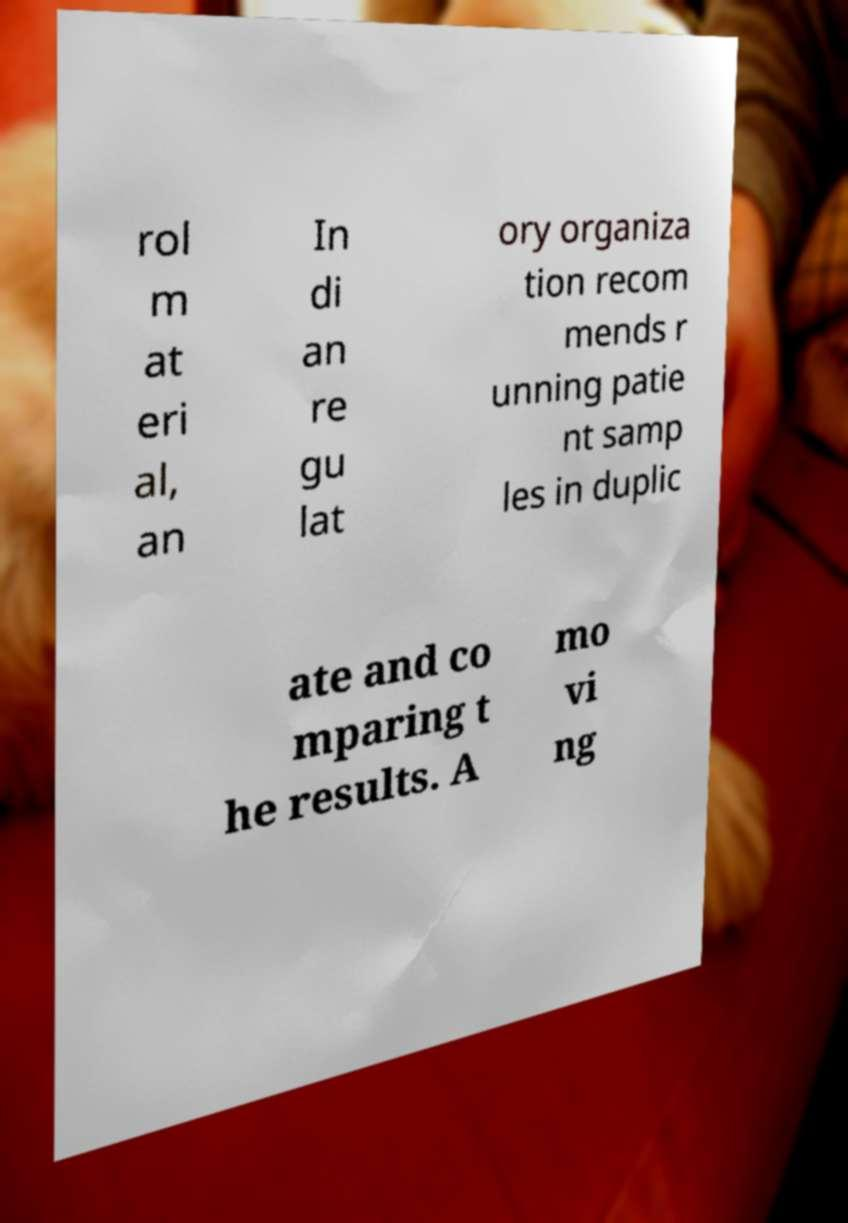For documentation purposes, I need the text within this image transcribed. Could you provide that? rol m at eri al, an In di an re gu lat ory organiza tion recom mends r unning patie nt samp les in duplic ate and co mparing t he results. A mo vi ng 